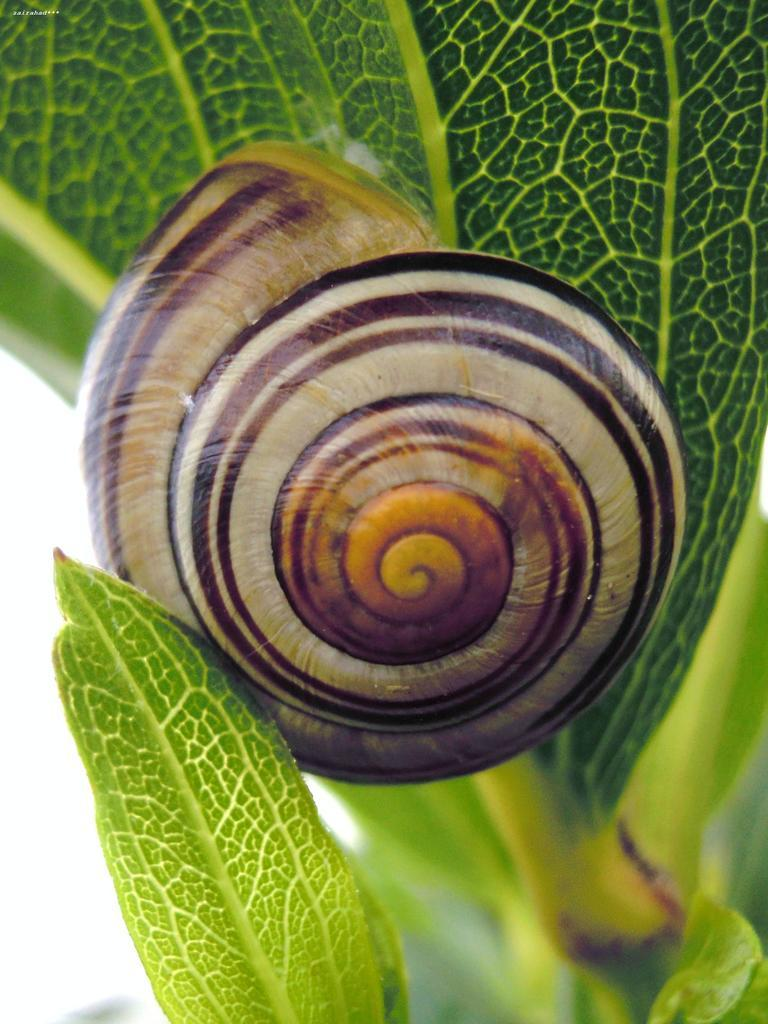What type of animal is in the image? There is a snail in the image. Where is the snail located? The snail is on a plant. What type of clouds can be seen in the image? There are no clouds visible in the image, as it features a snail on a plant. How many cows are present in the image? There are no cows present in the image; it only features a snail on a plant. 